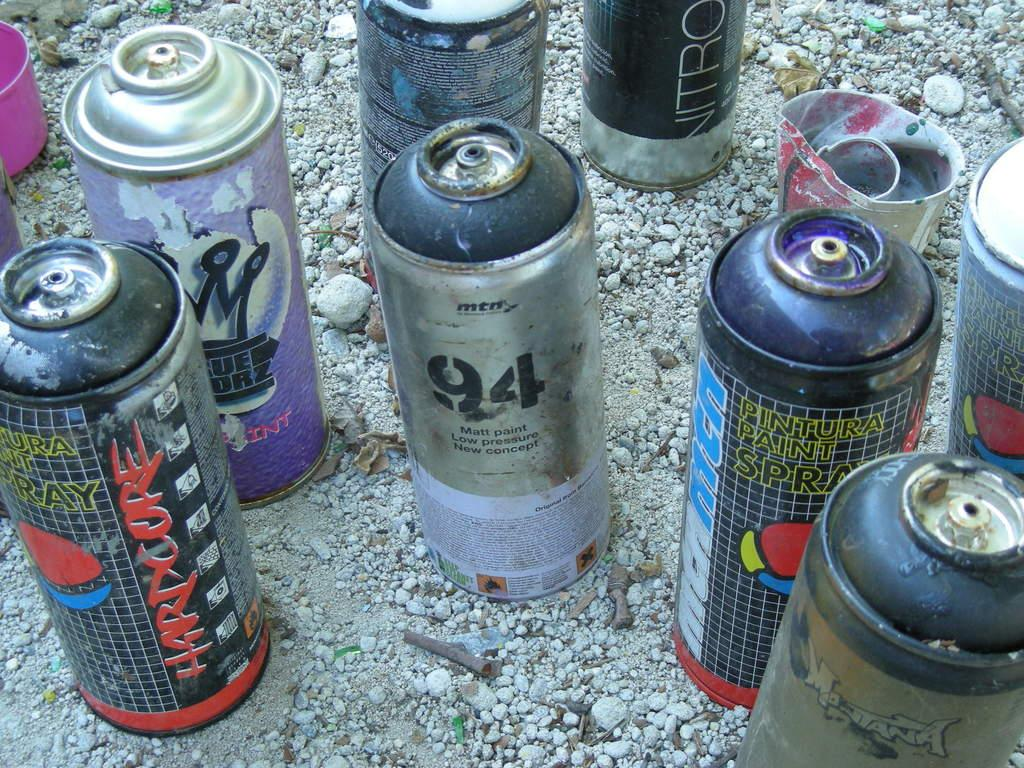<image>
Present a compact description of the photo's key features. A can of spray paint that says 94 on it sits with many other cans. 